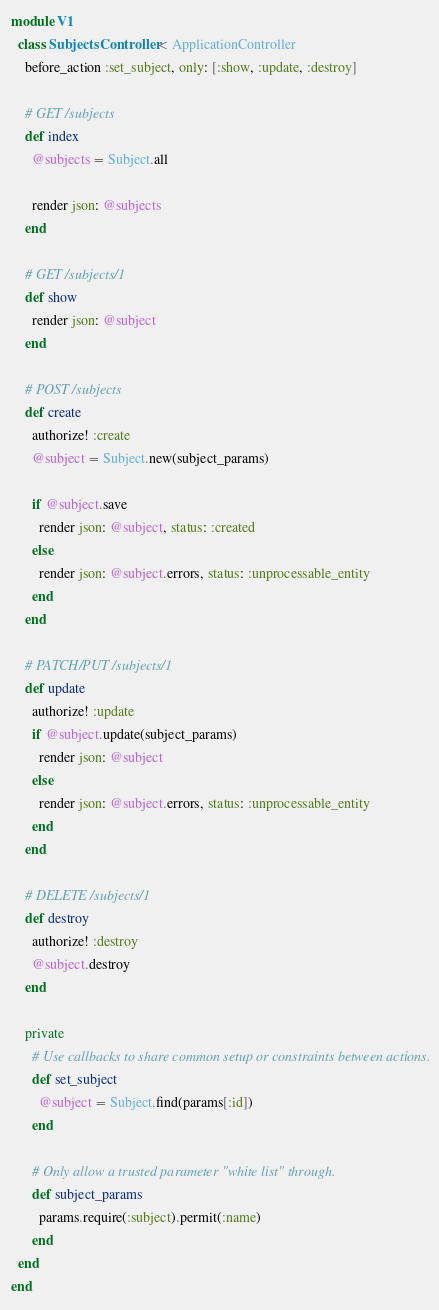<code> <loc_0><loc_0><loc_500><loc_500><_Ruby_>module V1
  class SubjectsController < ApplicationController
    before_action :set_subject, only: [:show, :update, :destroy]

    # GET /subjects
    def index
      @subjects = Subject.all

      render json: @subjects
    end

    # GET /subjects/1
    def show
      render json: @subject
    end

    # POST /subjects
    def create
      authorize! :create
      @subject = Subject.new(subject_params)

      if @subject.save
        render json: @subject, status: :created
      else
        render json: @subject.errors, status: :unprocessable_entity
      end
    end

    # PATCH/PUT /subjects/1
    def update
      authorize! :update
      if @subject.update(subject_params)
        render json: @subject
      else
        render json: @subject.errors, status: :unprocessable_entity
      end
    end

    # DELETE /subjects/1
    def destroy
      authorize! :destroy
      @subject.destroy
    end

    private
      # Use callbacks to share common setup or constraints between actions.
      def set_subject
        @subject = Subject.find(params[:id])
      end

      # Only allow a trusted parameter "white list" through.
      def subject_params
        params.require(:subject).permit(:name)
      end
  end
end
</code> 